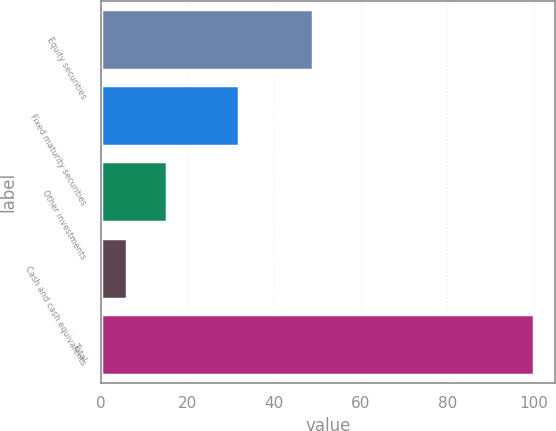Convert chart to OTSL. <chart><loc_0><loc_0><loc_500><loc_500><bar_chart><fcel>Equity securities<fcel>Fixed maturity securities<fcel>Other investments<fcel>Cash and cash equivalents<fcel>Total<nl><fcel>49<fcel>32<fcel>15.4<fcel>6<fcel>100<nl></chart> 